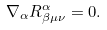<formula> <loc_0><loc_0><loc_500><loc_500>\nabla _ { \alpha } R ^ { \alpha } _ { \beta \mu \nu } = 0 .</formula> 